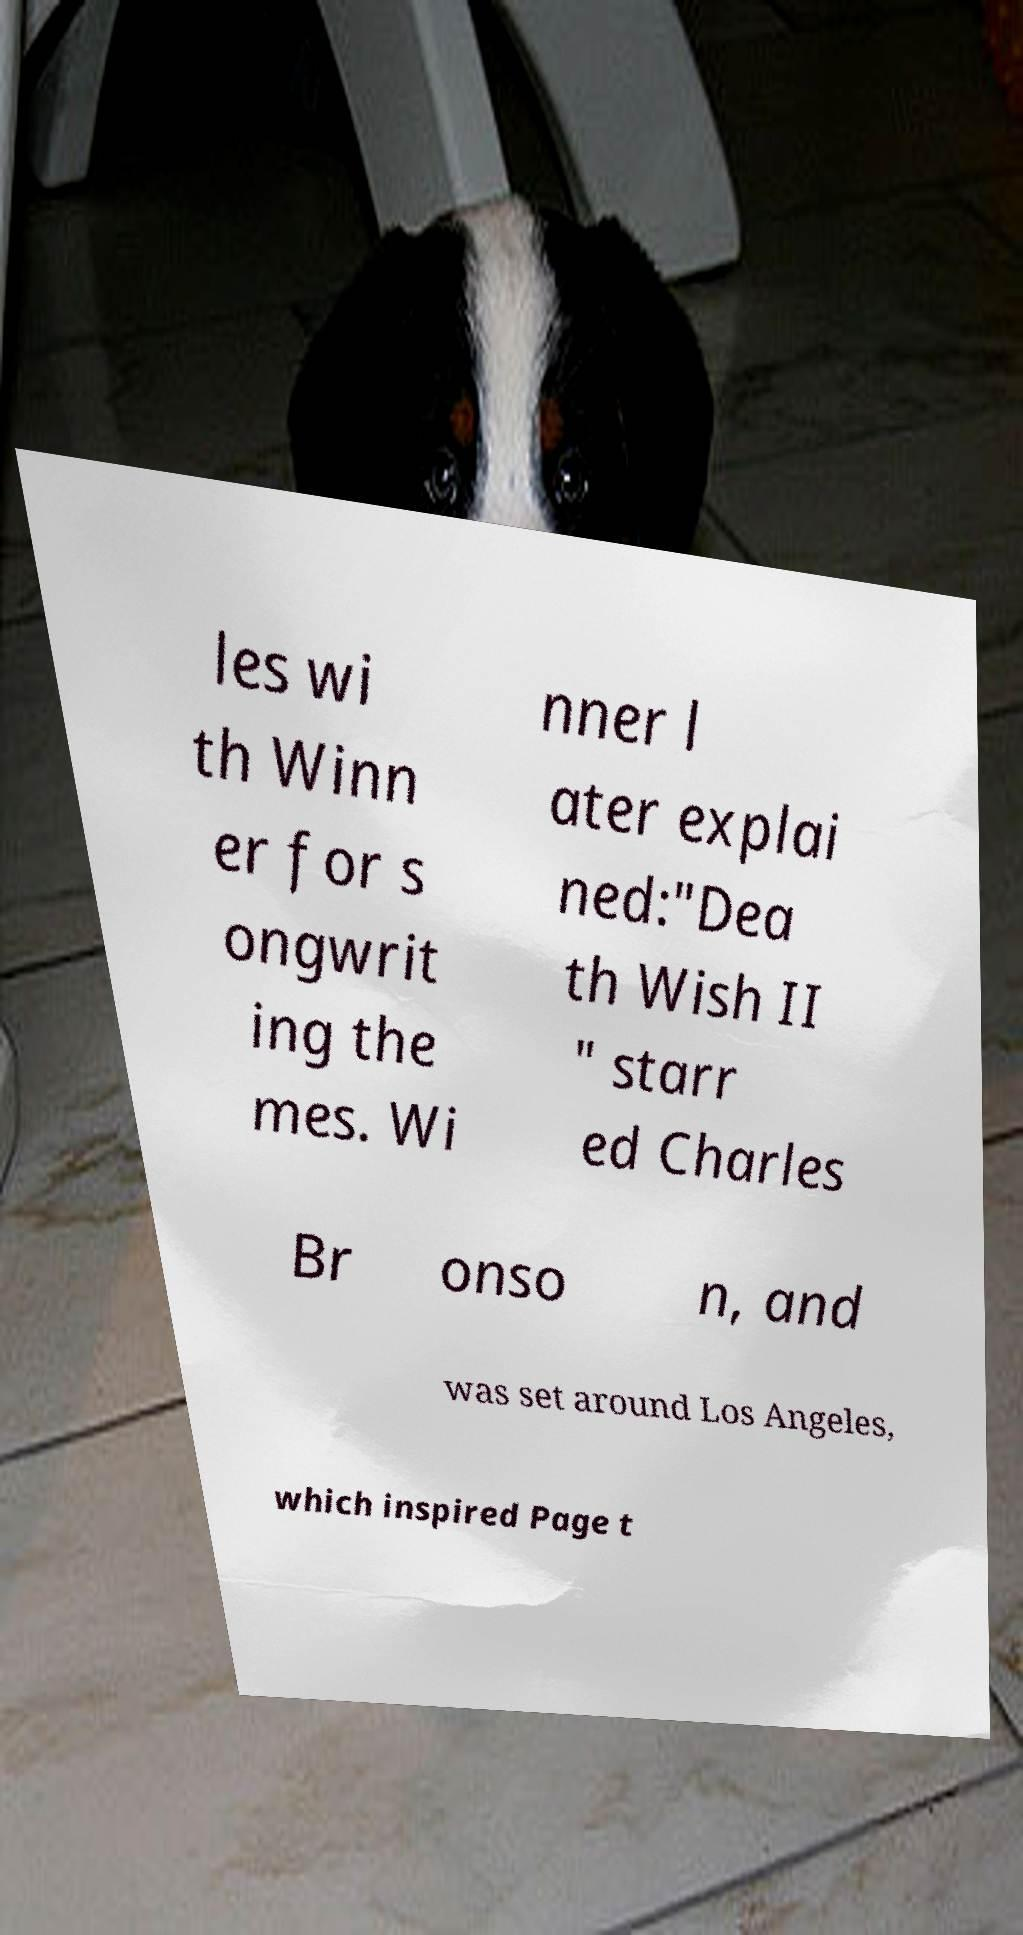I need the written content from this picture converted into text. Can you do that? les wi th Winn er for s ongwrit ing the mes. Wi nner l ater explai ned:"Dea th Wish II " starr ed Charles Br onso n, and was set around Los Angeles, which inspired Page t 